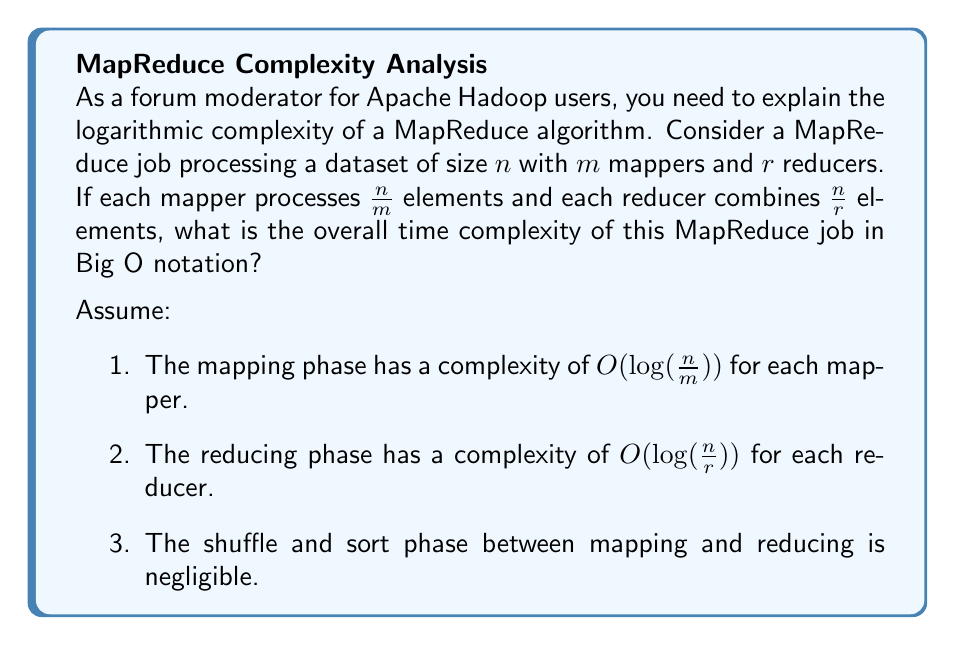Provide a solution to this math problem. Let's break down the problem and analyze each phase:

1. Mapping phase:
   - Each mapper processes $\frac{n}{m}$ elements with a complexity of $O(\log(\frac{n}{m}))$
   - There are $m$ mappers working in parallel
   - The overall complexity of the mapping phase is $O(\log(\frac{n}{m}))$

2. Reducing phase:
   - Each reducer processes $\frac{n}{r}$ elements with a complexity of $O(\log(\frac{n}{r}))$
   - There are $r$ reducers working in parallel
   - The overall complexity of the reducing phase is $O(\log(\frac{n}{r}))$

3. Total complexity:
   - Since the mapping and reducing phases are sequential, we add their complexities
   - Total complexity = $O(\log(\frac{n}{m}) + \log(\frac{n}{r}))$

4. Simplify using logarithm properties:
   $$O(\log(\frac{n}{m}) + \log(\frac{n}{r})) = O(\log(\frac{n^2}{mr}))$$

5. Consider the relationship between $n$, $m$, and $r$:
   - In practice, $m$ and $r$ are typically much smaller than $n$
   - As $n$ grows, the impact of $m$ and $r$ becomes negligible
   - We can approximate the complexity as $O(\log(n^2)) = O(2\log(n))$

6. Final simplification:
   - Constants are dropped in Big O notation
   - $O(2\log(n))$ simplifies to $O(\log(n))$

Therefore, the overall time complexity of this MapReduce job is $O(\log(n))$.
Answer: $O(\log(n))$ 